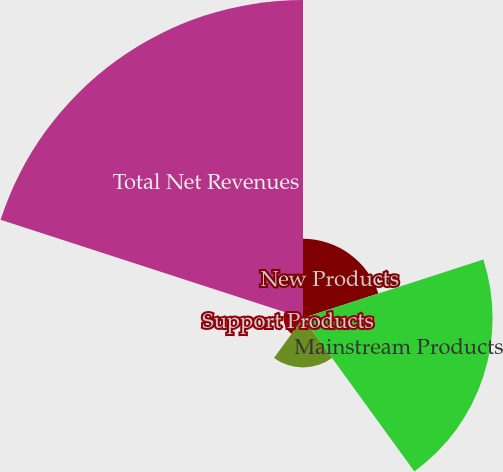<chart> <loc_0><loc_0><loc_500><loc_500><pie_chart><fcel>New Products<fcel>Mainstream Products<fcel>Base Products<fcel>Support Products<fcel>Total Net Revenues<nl><fcel>12.08%<fcel>28.91%<fcel>7.53%<fcel>2.98%<fcel>48.49%<nl></chart> 